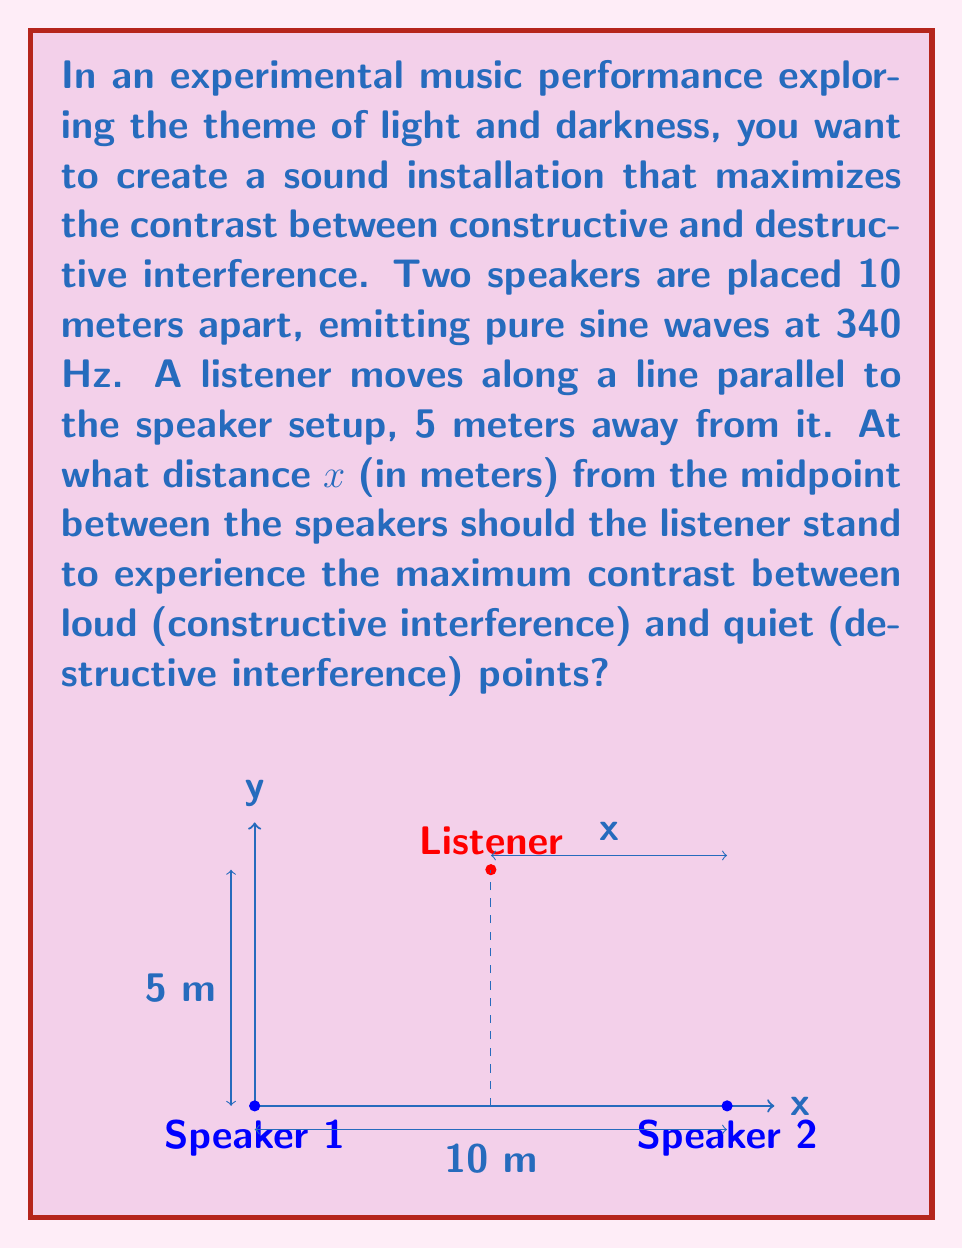Could you help me with this problem? Let's approach this step-by-step:

1) The speed of sound in air is approximately 340 m/s. The frequency is 340 Hz, so the wavelength λ is:

   $$λ = \frac{v}{f} = \frac{340 \text{ m/s}}{340 \text{ Hz}} = 1 \text{ m}$$

2) For maximum contrast, we want the path difference between the two waves to be half a wavelength (0.5 m). This will cause destructive interference at some points and constructive interference at others.

3) Let's call the distance from Speaker 1 to the listener $d_1$ and from Speaker 2 to the listener $d_2$. We want:

   $$|d_1 - d_2| = 0.5 \text{ m}$$

4) Using the Pythagorean theorem:

   $$d_1 = \sqrt{(5-x)^2 + 5^2}$$
   $$d_2 = \sqrt{(5+x)^2 + 5^2}$$

5) Substituting into our condition:

   $$\sqrt{(5+x)^2 + 5^2} - \sqrt{(5-x)^2 + 5^2} = 0.5$$

6) Squaring both sides:

   $$(5+x)^2 + 5^2 = ((5-x)^2 + 5^2 + 0.5)^2$$

7) Expanding:

   $$50 + 20x + x^2 = 50 - 20x + x^2 + 50 + 0.25 + (5-x)\sqrt{50-20x+x^2}$$

8) Simplifying:

   $$40x = 50.25 + (5-x)\sqrt{50-20x+x^2}$$

9) This equation can be solved numerically. The solution is approximately:

   $$x ≈ 2.165 \text{ m}$$

This means the listener should stand about 2.165 meters to the right of the midpoint between the speakers for maximum contrast.
Answer: 2.165 m 